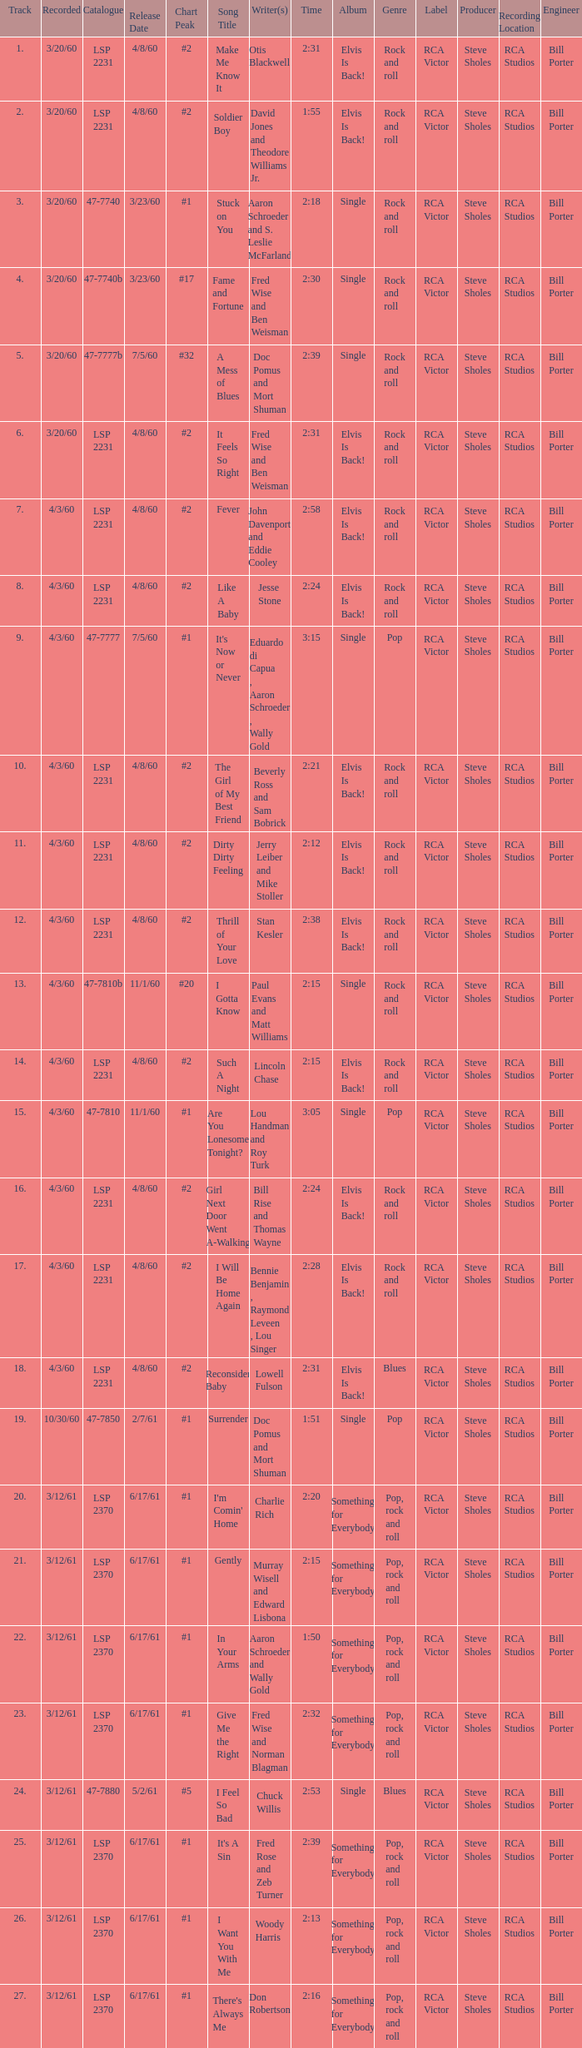On songs with track numbers smaller than number 17 and catalogues of LSP 2231, who are the writer(s)? Otis Blackwell, David Jones and Theodore Williams Jr., Fred Wise and Ben Weisman, John Davenport and Eddie Cooley, Jesse Stone, Beverly Ross and Sam Bobrick, Jerry Leiber and Mike Stoller, Stan Kesler, Lincoln Chase, Bill Rise and Thomas Wayne. 